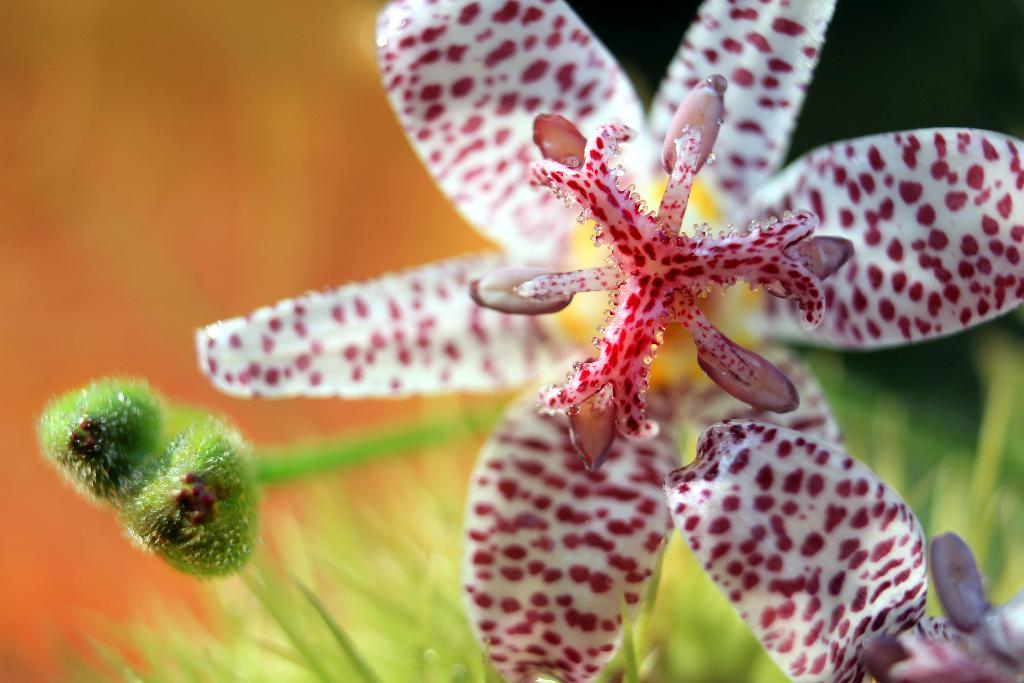What type of plants can be seen in the image? There are flowers in the image. Are there any unopened flowers in the image? Yes, there are buds in the image. How would you describe the background of the image? The background of the image is blurred. Who is the creator of the ornament in the image? There is no ornament present in the image; it features flowers and buds. 